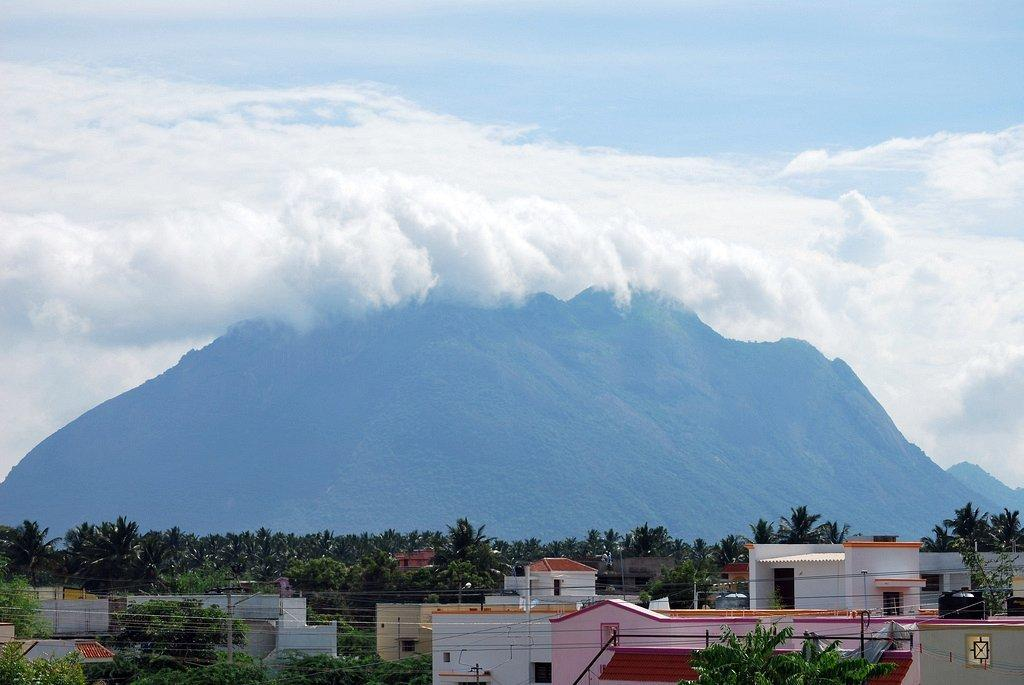What type of structure can be seen in the image? There is a building and a house in the image. What type of lighting is present in the image? Street lights are present in the image. What type of vegetation is visible in the image? There are many trees in the image. What can be seen in the background of the image? There is a mountain in the background of the image. What is visible at the top of the image? The sky is visible at the top of the image, and clouds are present in the sky. Can you see a gun being fired in the image? No, there is no gun or any indication of a gun being fired in the image. Is there a person kneeling down in the image? There is no person visible in the image, so it is impossible to determine if someone is kneeling down. 